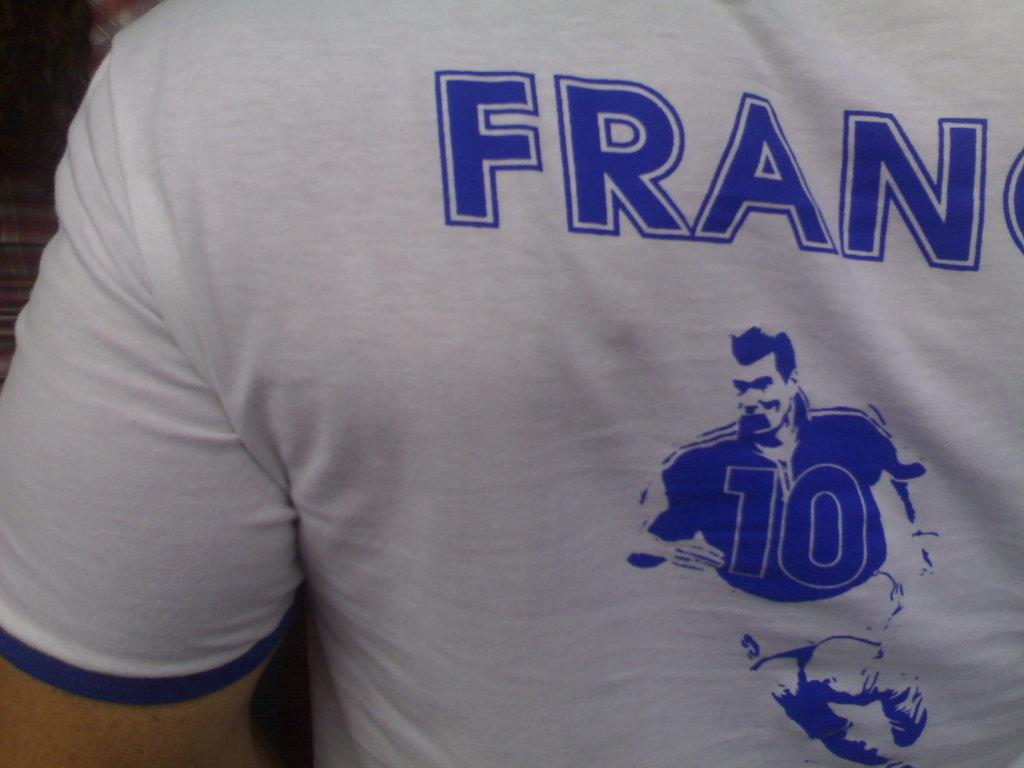Provide a one-sentence caption for the provided image. A t-shirt depicting a football player with the number 10 on the front of the jersey. 